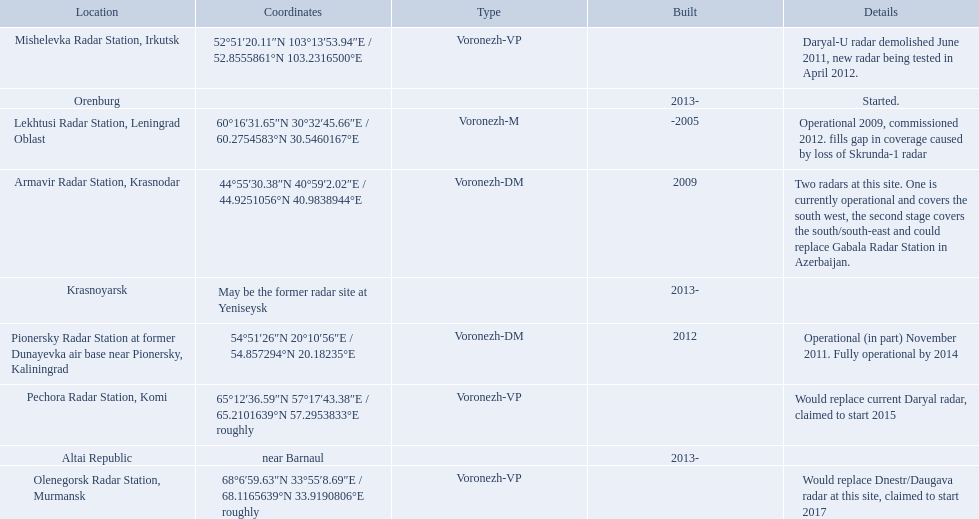What are the list of radar locations? Lekhtusi Radar Station, Leningrad Oblast, Armavir Radar Station, Krasnodar, Pionersky Radar Station at former Dunayevka air base near Pionersky, Kaliningrad, Mishelevka Radar Station, Irkutsk, Pechora Radar Station, Komi, Olenegorsk Radar Station, Murmansk, Krasnoyarsk, Altai Republic, Orenburg. Which of these are claimed to start in 2015? Pechora Radar Station, Komi. 